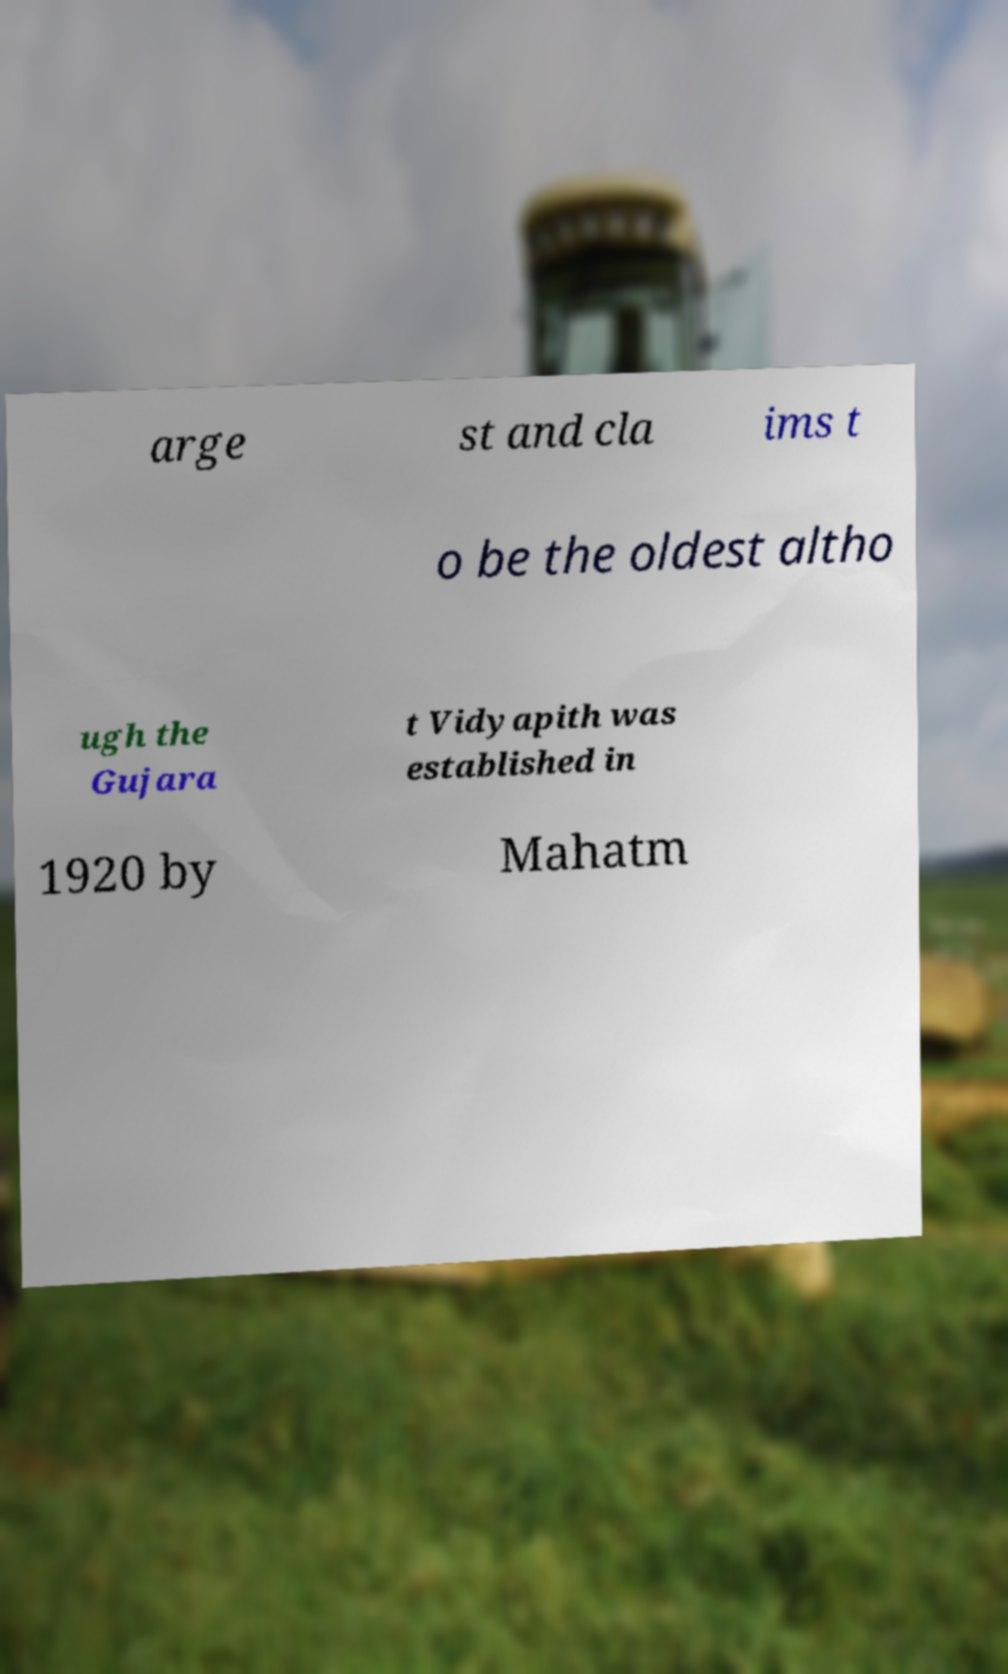Can you read and provide the text displayed in the image?This photo seems to have some interesting text. Can you extract and type it out for me? arge st and cla ims t o be the oldest altho ugh the Gujara t Vidyapith was established in 1920 by Mahatm 